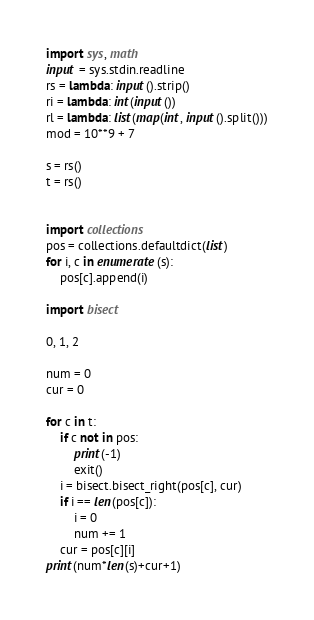Convert code to text. <code><loc_0><loc_0><loc_500><loc_500><_Python_>import sys, math
input = sys.stdin.readline
rs = lambda: input().strip()
ri = lambda: int(input())
rl = lambda: list(map(int, input().split()))
mod = 10**9 + 7

s = rs()
t = rs()


import collections
pos = collections.defaultdict(list)
for i, c in enumerate(s):
	pos[c].append(i)

import bisect

0, 1, 2

num = 0
cur = 0

for c in t:
	if c not in pos:
		print(-1)
		exit()
	i = bisect.bisect_right(pos[c], cur)
	if i == len(pos[c]):
		i = 0
		num += 1
	cur = pos[c][i]
print(num*len(s)+cur+1)

</code> 